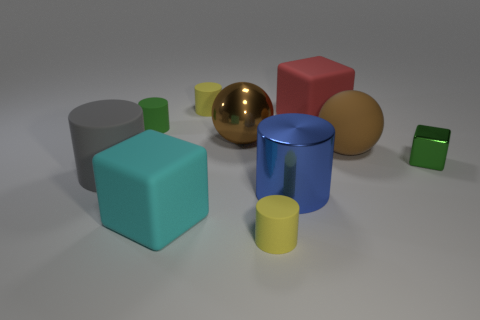Subtract all yellow blocks. How many yellow cylinders are left? 2 Subtract all green shiny blocks. How many blocks are left? 2 Subtract all blue cylinders. How many cylinders are left? 4 Subtract 1 blocks. How many blocks are left? 2 Subtract all small rubber blocks. Subtract all large rubber spheres. How many objects are left? 9 Add 4 tiny metallic cubes. How many tiny metallic cubes are left? 5 Add 6 cyan blocks. How many cyan blocks exist? 7 Subtract 0 blue spheres. How many objects are left? 10 Subtract all cubes. How many objects are left? 7 Subtract all gray balls. Subtract all gray cubes. How many balls are left? 2 